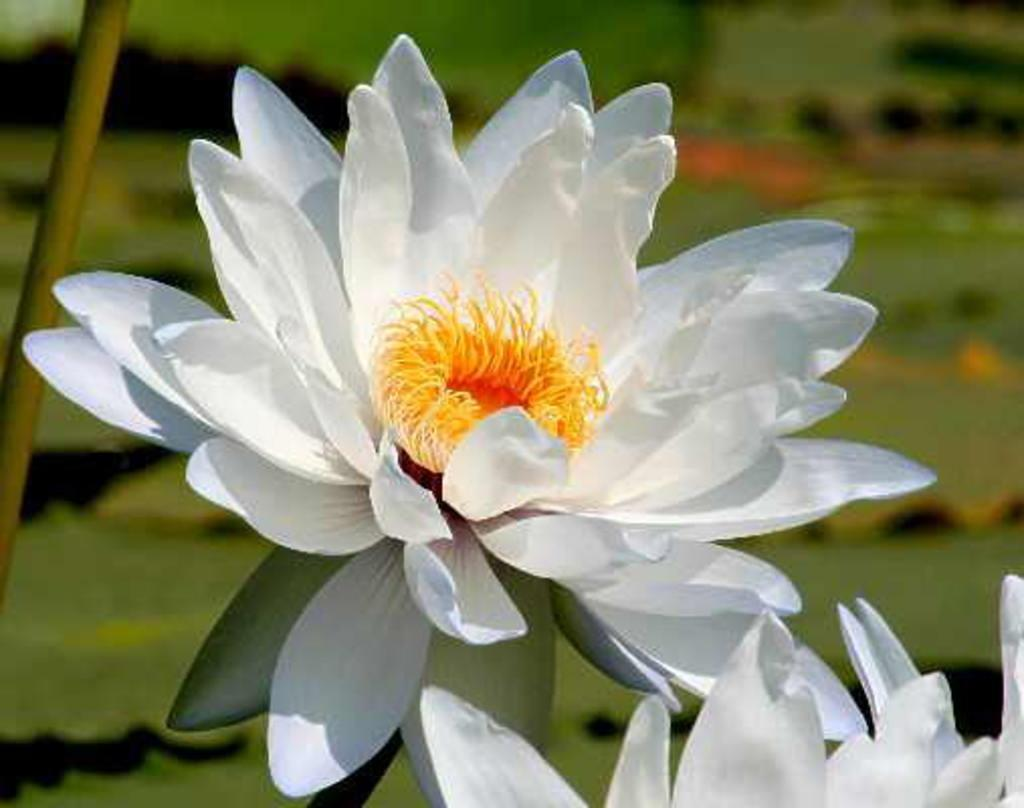What types of plants are in the foreground of the image? There are two flowers in the foreground of the image. What can be seen in the background of the image? There are plants in the background of the image. What type of coach can be seen driving through the town in the image? There is no coach or town present in the image, as it features only flowers and plants. 